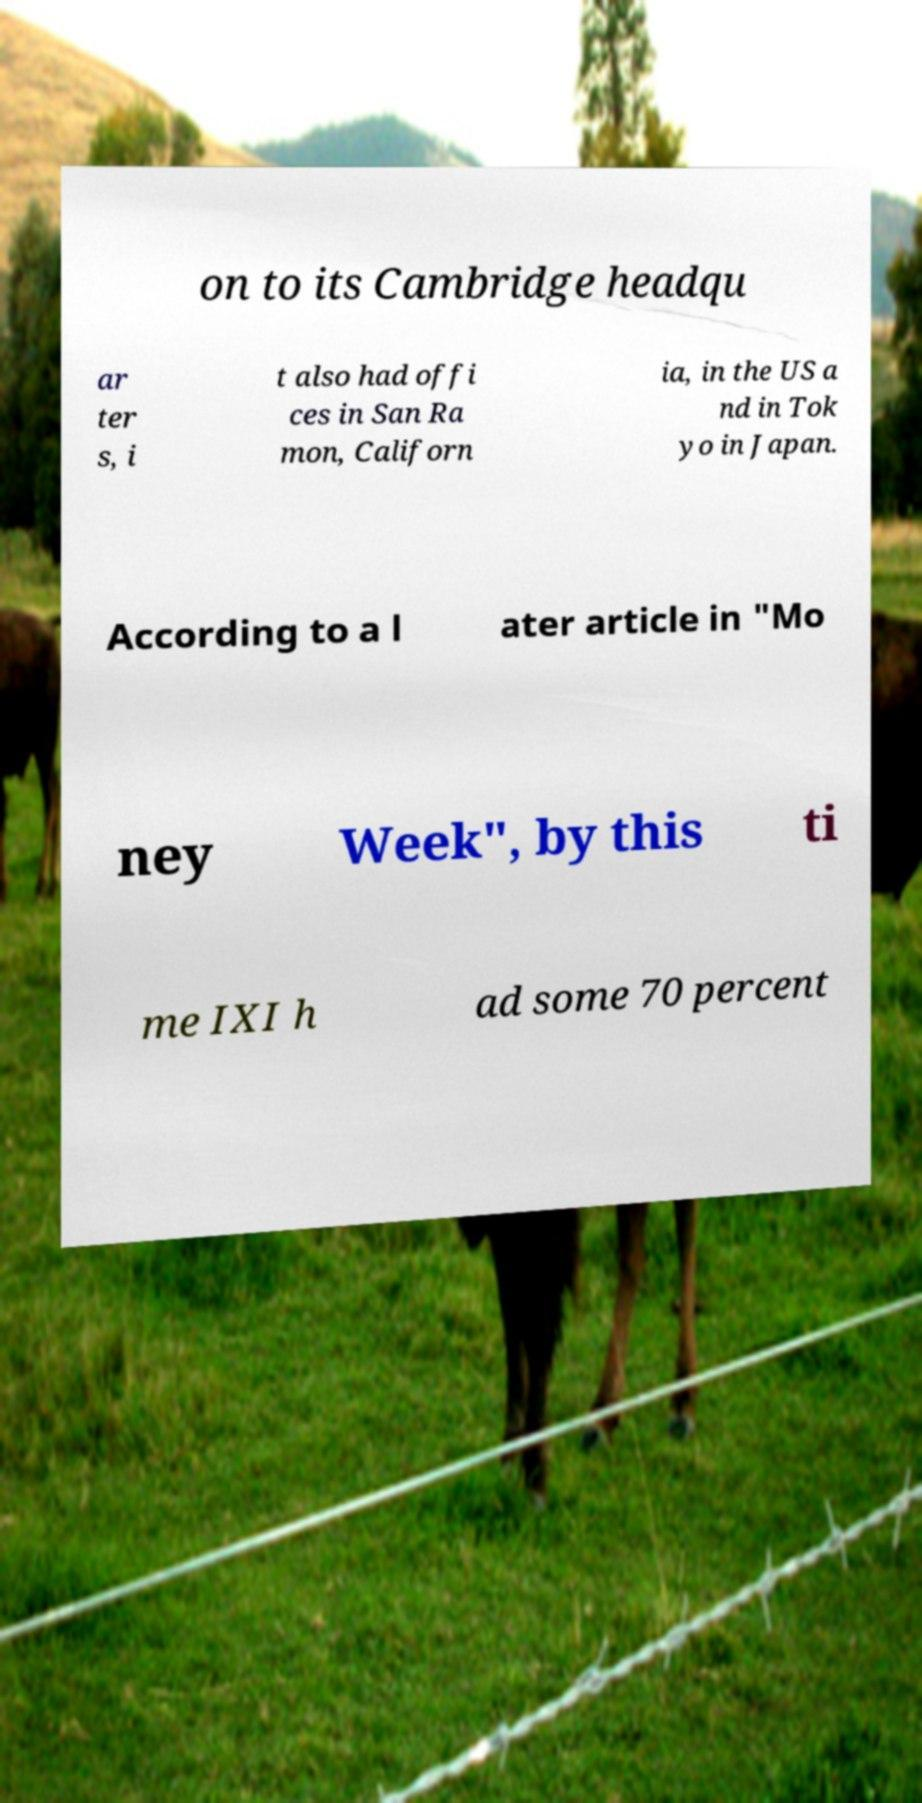For documentation purposes, I need the text within this image transcribed. Could you provide that? on to its Cambridge headqu ar ter s, i t also had offi ces in San Ra mon, Californ ia, in the US a nd in Tok yo in Japan. According to a l ater article in "Mo ney Week", by this ti me IXI h ad some 70 percent 